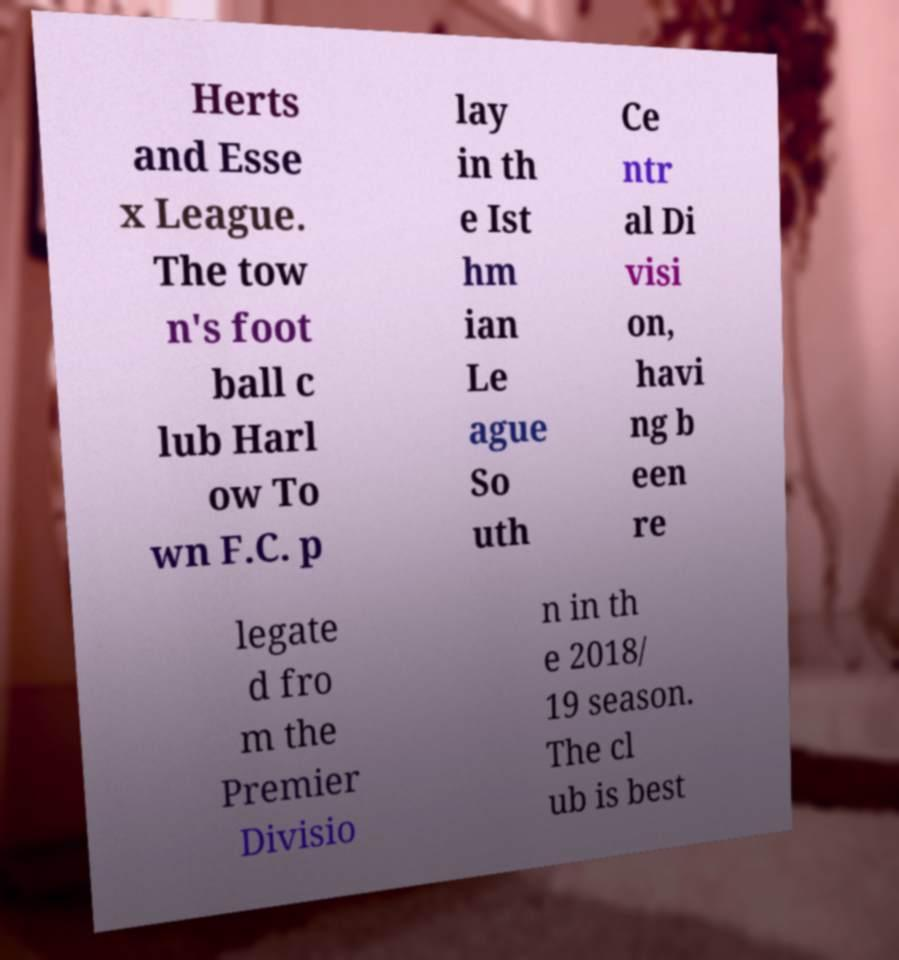Could you assist in decoding the text presented in this image and type it out clearly? Herts and Esse x League. The tow n's foot ball c lub Harl ow To wn F.C. p lay in th e Ist hm ian Le ague So uth Ce ntr al Di visi on, havi ng b een re legate d fro m the Premier Divisio n in th e 2018/ 19 season. The cl ub is best 